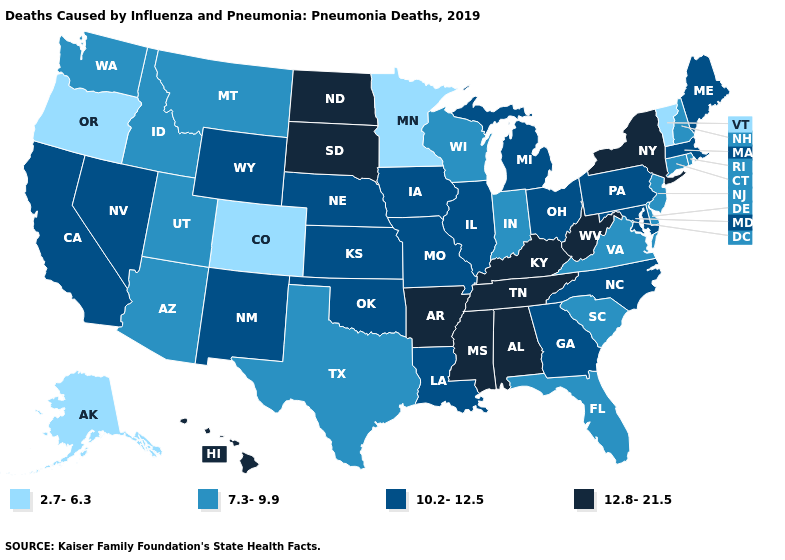Among the states that border California , does Oregon have the lowest value?
Concise answer only. Yes. Does Alabama have the lowest value in the South?
Short answer required. No. Name the states that have a value in the range 12.8-21.5?
Keep it brief. Alabama, Arkansas, Hawaii, Kentucky, Mississippi, New York, North Dakota, South Dakota, Tennessee, West Virginia. Name the states that have a value in the range 2.7-6.3?
Be succinct. Alaska, Colorado, Minnesota, Oregon, Vermont. What is the value of Alabama?
Quick response, please. 12.8-21.5. What is the value of South Carolina?
Write a very short answer. 7.3-9.9. Among the states that border Minnesota , does North Dakota have the highest value?
Be succinct. Yes. Which states have the lowest value in the USA?
Concise answer only. Alaska, Colorado, Minnesota, Oregon, Vermont. Name the states that have a value in the range 7.3-9.9?
Give a very brief answer. Arizona, Connecticut, Delaware, Florida, Idaho, Indiana, Montana, New Hampshire, New Jersey, Rhode Island, South Carolina, Texas, Utah, Virginia, Washington, Wisconsin. What is the value of South Carolina?
Write a very short answer. 7.3-9.9. Among the states that border Idaho , which have the highest value?
Short answer required. Nevada, Wyoming. Name the states that have a value in the range 7.3-9.9?
Write a very short answer. Arizona, Connecticut, Delaware, Florida, Idaho, Indiana, Montana, New Hampshire, New Jersey, Rhode Island, South Carolina, Texas, Utah, Virginia, Washington, Wisconsin. What is the lowest value in states that border Wyoming?
Concise answer only. 2.7-6.3. Which states have the lowest value in the MidWest?
Concise answer only. Minnesota. 